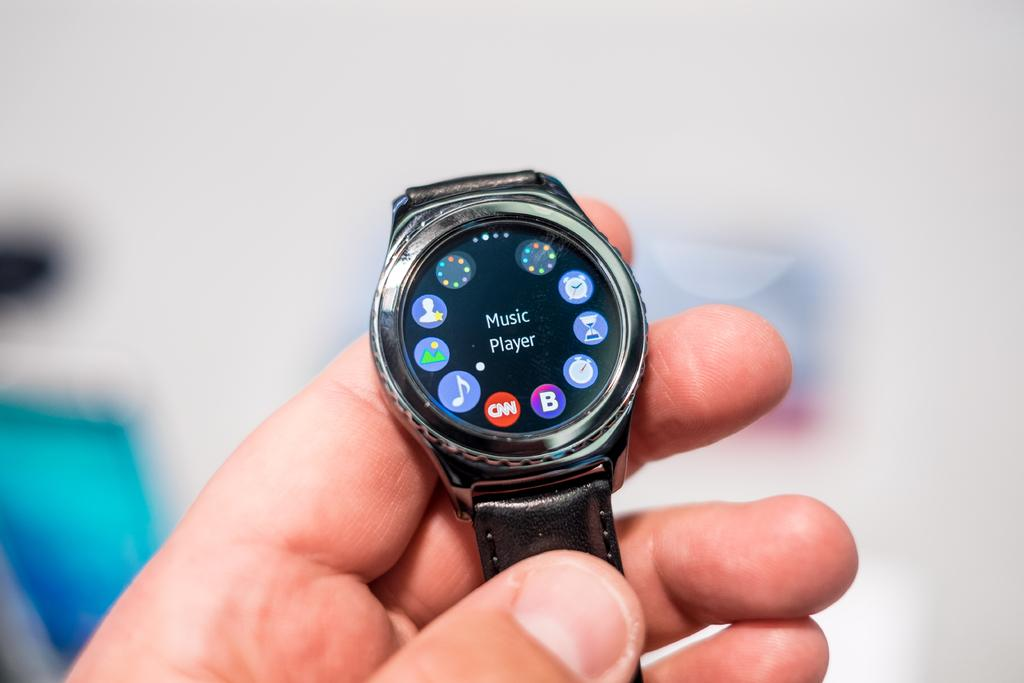<image>
Write a terse but informative summary of the picture. A watch has a music player showing on the screen. 